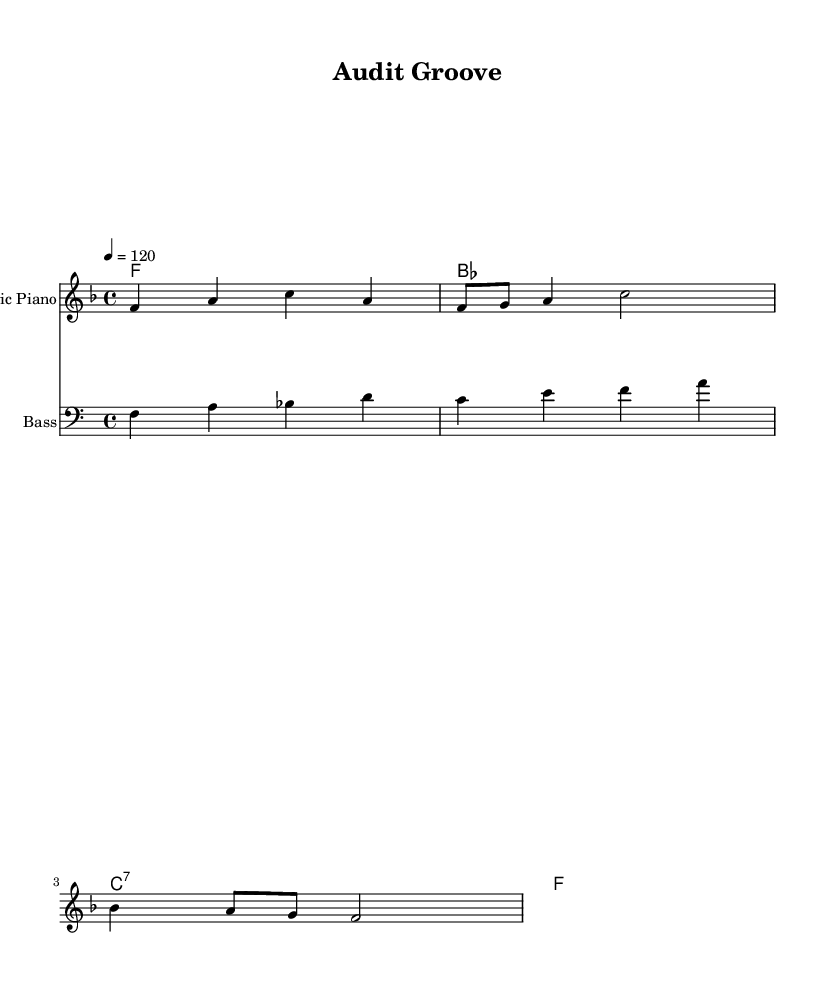What is the key signature of this music? The key signature is F major, which has one flat (B flat). This can be identified by looking at the key signature indicated at the beginning of the staff.
Answer: F major What is the time signature of this music? The time signature is indicated as 4/4, meaning there are four beats per measure and the quarter note receives one beat. This is shown at the beginning of the staff as well.
Answer: 4/4 What is the tempo marking of this piece? The tempo marking is set at 120 beats per minute, indicated by the tempo text "4 = 120" at the beginning of the score. This denotes the speed at which the music should be played.
Answer: 120 How many measures are in the melody section? The melody section consists of four measures, which can be counted by looking at the vertical bar lines separating each measure in the melody staff.
Answer: 4 What is the primary instrumental role featured in this score? The primary instrumental role is depicted as "Electric Piano," which appears as the instrument name on one of the staves. This indicates the main melodic line is played on this instrument.
Answer: Electric Piano What is the first note of the melody? The first note of the melody is F, which is highlighted at the beginning of the melody section. Looking at the staff and identifying the note that appears first gives you this answer.
Answer: F What type of chord is shown in measure 3 of the harmony section? The chord in measure 3 is a C7 chord, denoted by the "c:7" label. This indicates a dominant seventh chord built on C. The chord quality and structure can be derived from its label in the chord names staff.
Answer: C7 